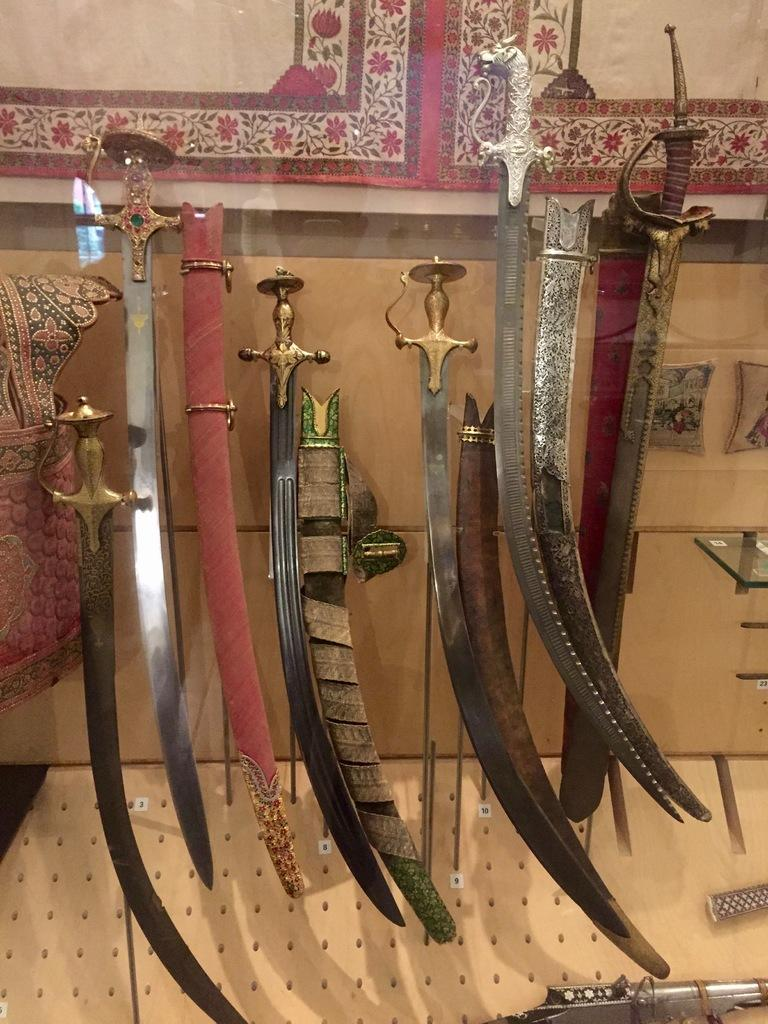What objects are present in the image? There are swords and a cloth in the image. Can you describe the position of the cloth in the image? The cloth is on the top and on the left side of the image. How many trees can be seen in the image? There are no trees present in the image. What type of hair is visible on the swords in the image? There is no hair visible on the swords in the image. 